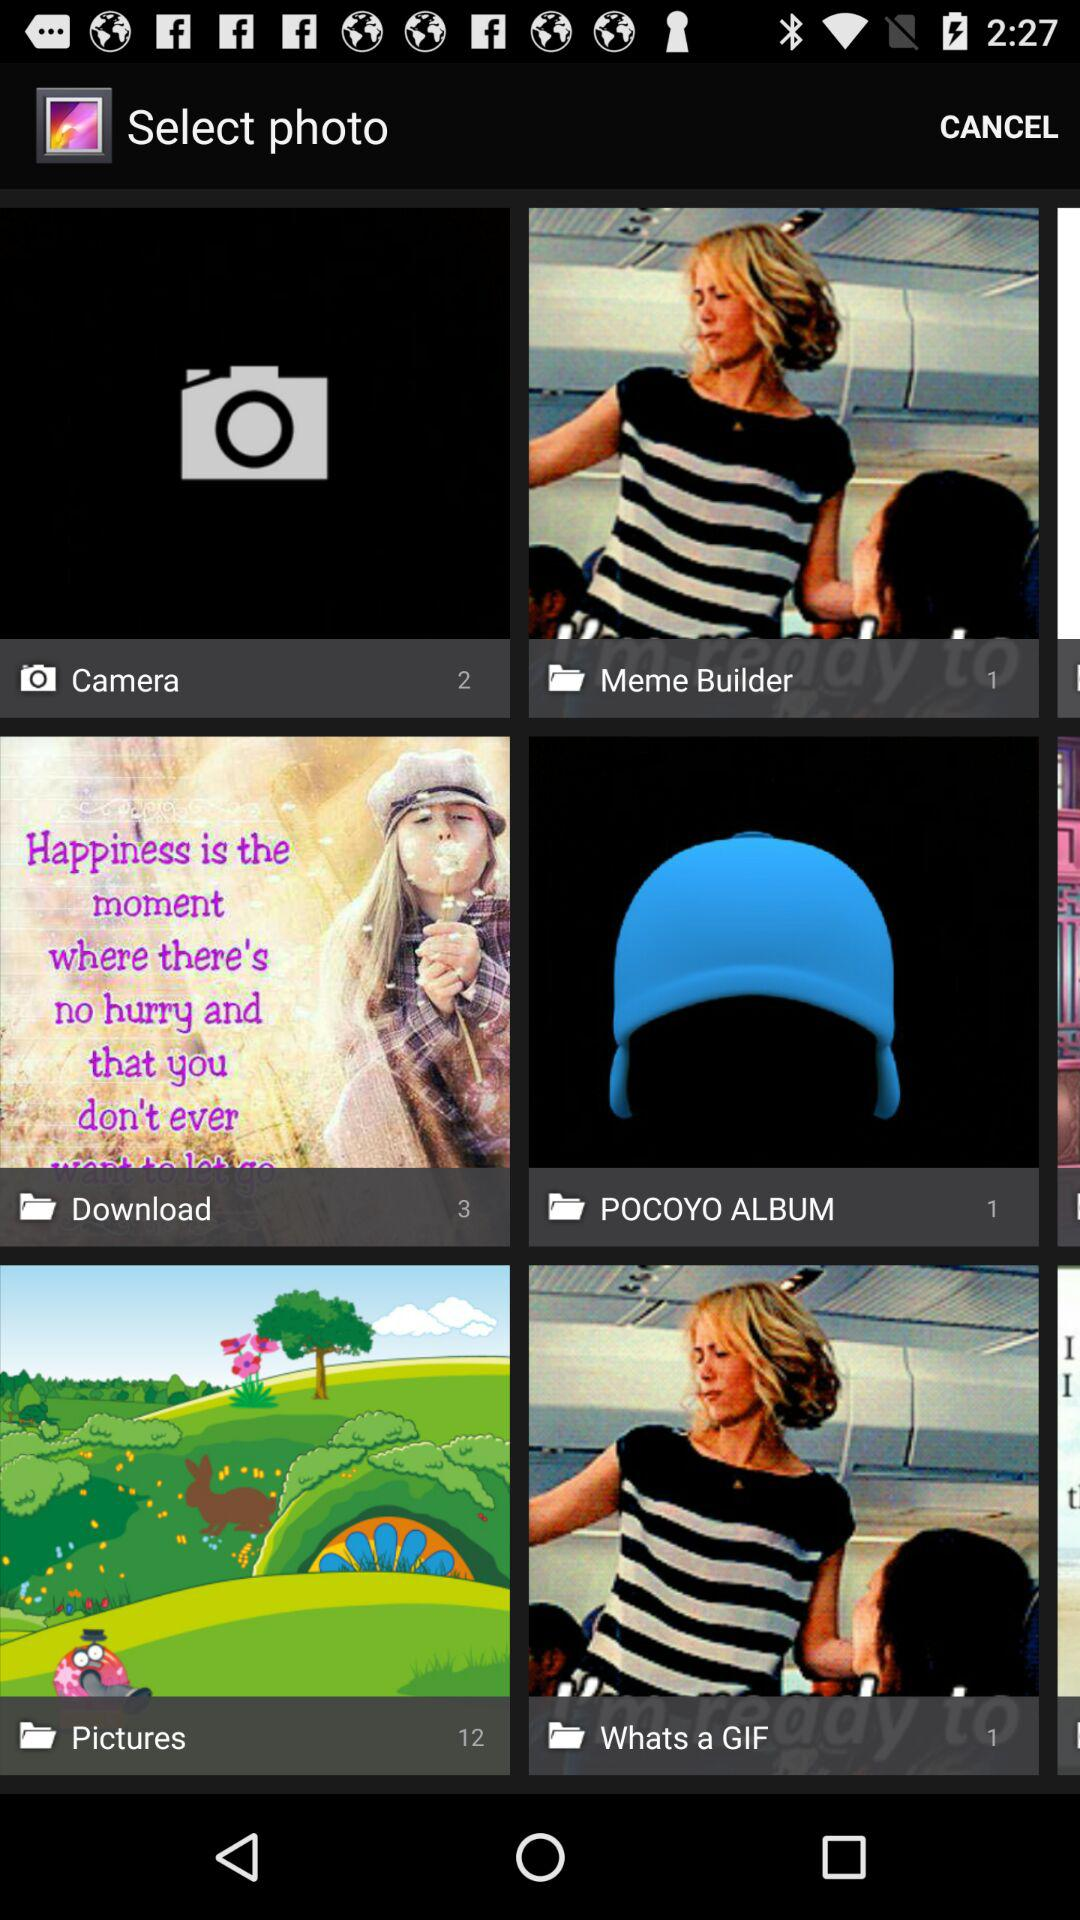What is the number of photos in the "Pictures" folder? The number of photos in the "Pictures" folder is 12. 